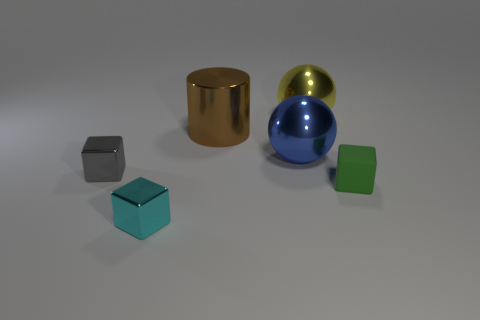Do the blue thing and the green object have the same material?
Provide a short and direct response. No. What number of things are either things that are behind the brown cylinder or objects in front of the small gray metallic object?
Make the answer very short. 3. The other thing that is the same shape as the blue metallic thing is what color?
Offer a very short reply. Yellow. What number of objects are either metallic objects that are in front of the big yellow object or small red rubber objects?
Your answer should be compact. 4. There is a cube to the right of the metallic thing that is in front of the cube to the left of the small cyan cube; what color is it?
Make the answer very short. Green. There is another tiny block that is the same material as the gray cube; what is its color?
Offer a very short reply. Cyan. What number of tiny blue things have the same material as the gray block?
Ensure brevity in your answer.  0. Does the metal sphere behind the cylinder have the same size as the tiny green object?
Make the answer very short. No. There is a metal cylinder that is the same size as the yellow sphere; what is its color?
Keep it short and to the point. Brown. How many blue things are in front of the large blue shiny ball?
Offer a very short reply. 0. 